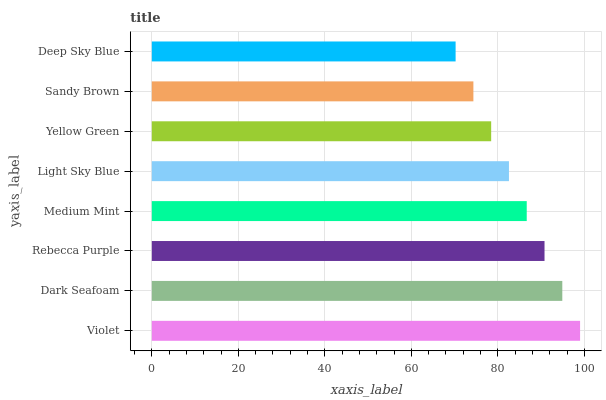Is Deep Sky Blue the minimum?
Answer yes or no. Yes. Is Violet the maximum?
Answer yes or no. Yes. Is Dark Seafoam the minimum?
Answer yes or no. No. Is Dark Seafoam the maximum?
Answer yes or no. No. Is Violet greater than Dark Seafoam?
Answer yes or no. Yes. Is Dark Seafoam less than Violet?
Answer yes or no. Yes. Is Dark Seafoam greater than Violet?
Answer yes or no. No. Is Violet less than Dark Seafoam?
Answer yes or no. No. Is Medium Mint the high median?
Answer yes or no. Yes. Is Light Sky Blue the low median?
Answer yes or no. Yes. Is Yellow Green the high median?
Answer yes or no. No. Is Dark Seafoam the low median?
Answer yes or no. No. 